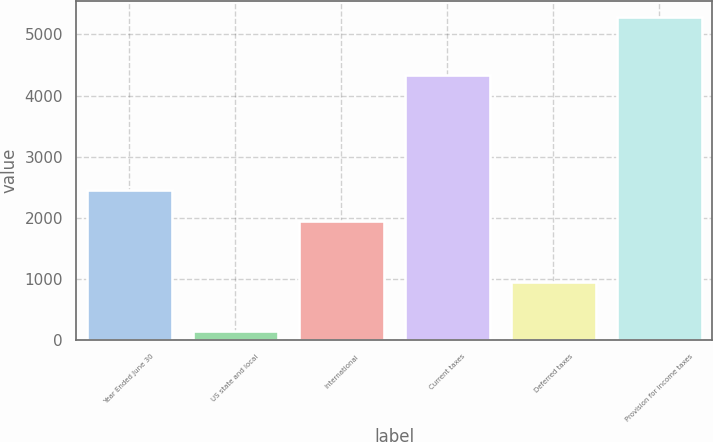<chart> <loc_0><loc_0><loc_500><loc_500><bar_chart><fcel>Year Ended June 30<fcel>US state and local<fcel>International<fcel>Current taxes<fcel>Deferred taxes<fcel>Provision for income taxes<nl><fcel>2460.6<fcel>153<fcel>1947<fcel>4335<fcel>954<fcel>5289<nl></chart> 